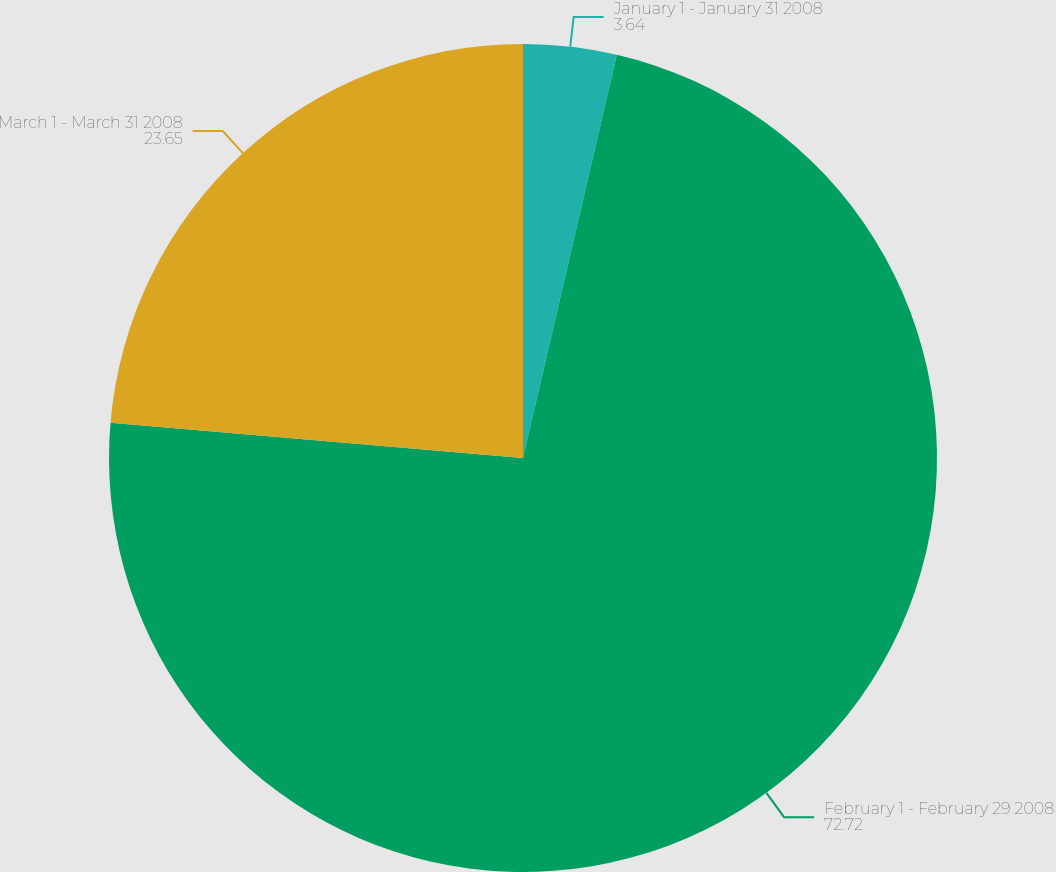Convert chart. <chart><loc_0><loc_0><loc_500><loc_500><pie_chart><fcel>January 1 - January 31 2008<fcel>February 1 - February 29 2008<fcel>March 1 - March 31 2008<nl><fcel>3.64%<fcel>72.72%<fcel>23.65%<nl></chart> 